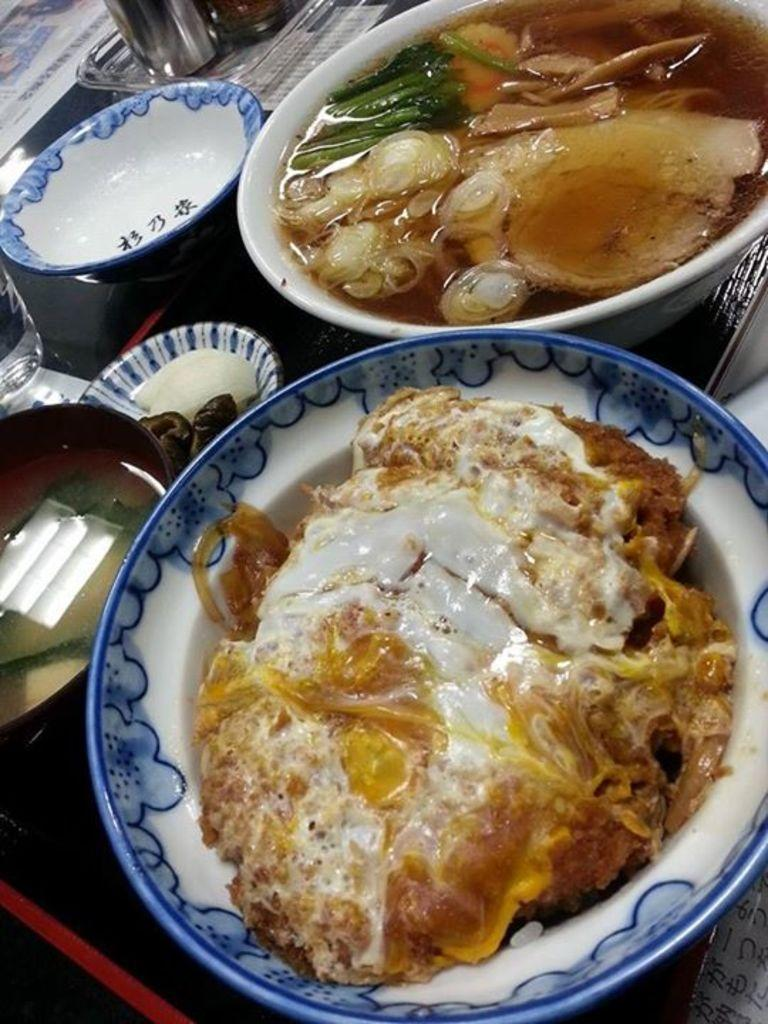What type of containers are used for the food items in the image? There are bowls and plates used for the food items in the image. What type of beverage container is present in the image? There is a glass in the image. What type of writing material is present in the image? There are papers in the image. What type of liquid container is present in the image? There is a bottle in the image. Where are all these items located in the image? All of these items are on a table in the image. What type of mountain can be seen in the background of the image? There is no mountain present in the image; it only features items on a table. 